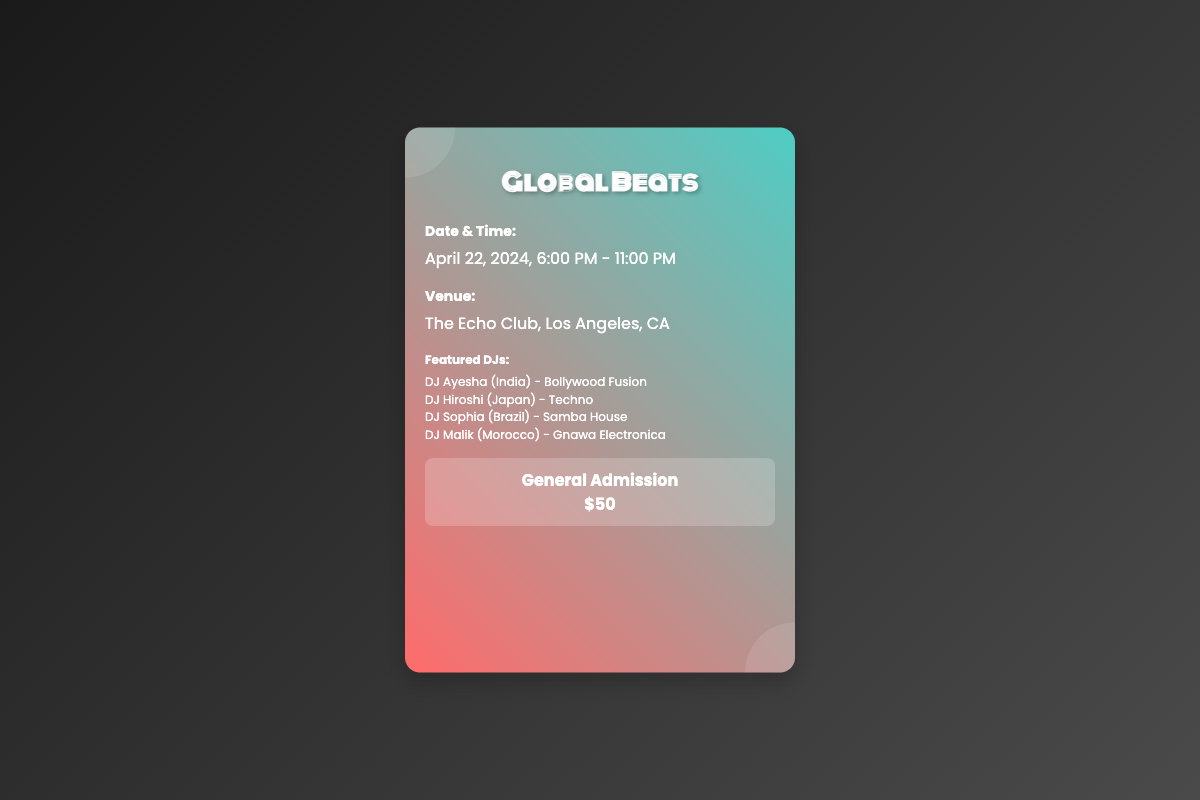What is the event title? The title of the event is prominently displayed at the top of the ticket.
Answer: Global Beats What date is the event scheduled for? The date is mentioned in the 'Date & Time' section of the ticket.
Answer: April 22, 2024 What is the venue for the event? The venue information is provided under the 'Venue' section.
Answer: The Echo Club, Los Angeles, CA How many featured DJs are listed on the ticket? By counting the listed DJs, we determine the total.
Answer: 4 What is the admission price? The ticket specifies the price under the 'General Admission' section.
Answer: $50 Which DJ represents Japan? The document mentions the DJs and their respective countries, allowing for identification.
Answer: DJ Hiroshi What genre does DJ Ayesha play? The DJ's genre is stated in the 'Featured DJs' section, along with their names and countries.
Answer: Bollywood Fusion What time does the event start? The starting time is included in the 'Date & Time' section of the ticket.
Answer: 6:00 PM Is there a QR code included in the ticket? The presence of a graphic indicates the inclusion of a QR code.
Answer: Yes 